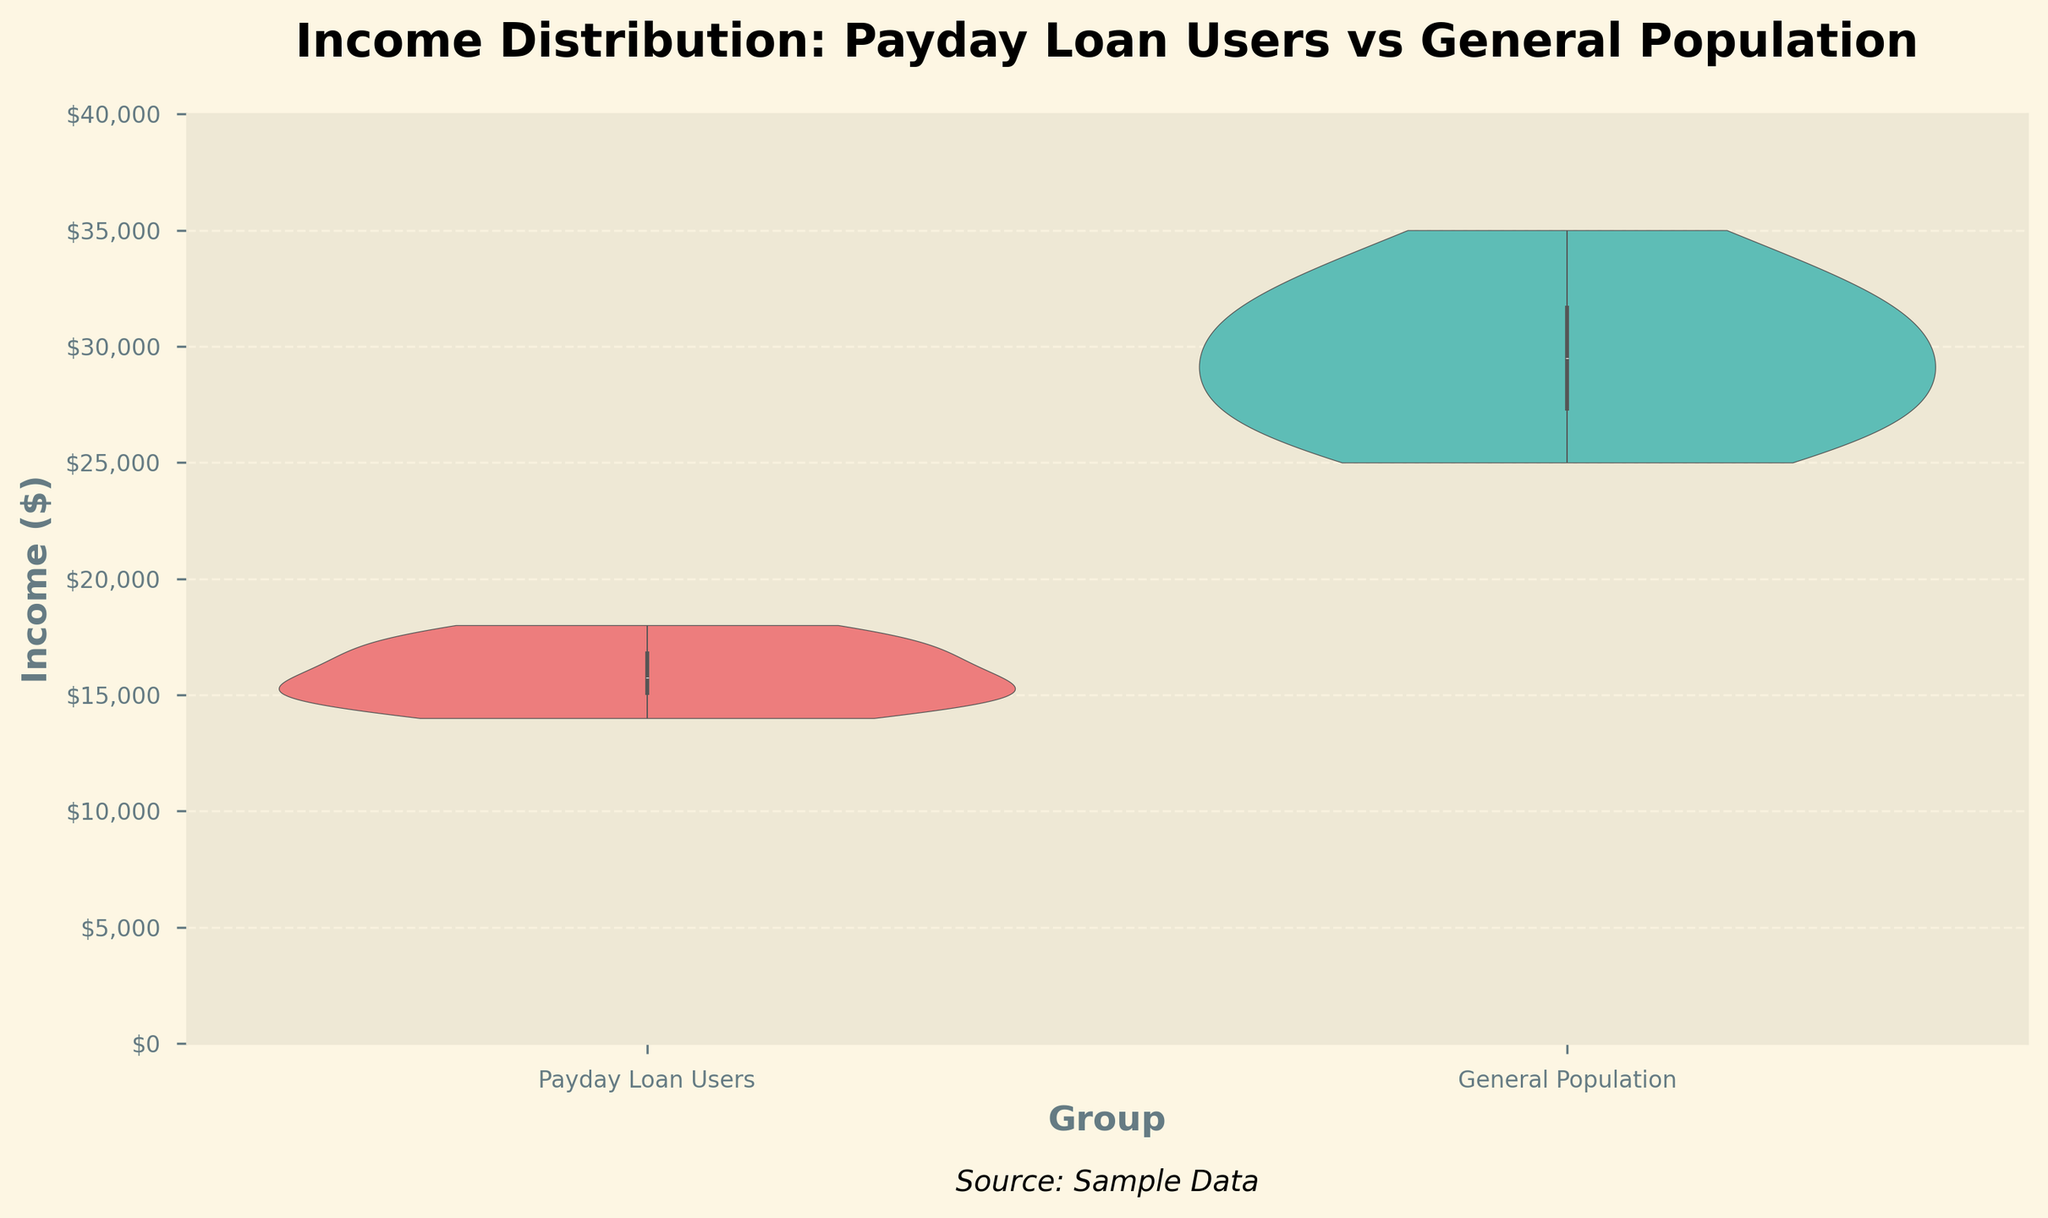What is the title of the figure? The title of the figure is located at the top and provides a summary of what the figure represents. By referring to the figure, we can see the title mentioned in bold font.
Answer: Income Distribution: Payday Loan Users vs General Population What is the highest income value shown on the y-axis? The y-axis represents the income levels and is marked with ticks ranging from 0 to 40,000. The highest tick mark visible on the y-axis can be observed directly from the figure.
Answer: $40,000 What colors are used for the groups in the figure? By referring to the colored sections of the violin plots in the figure, we can identify the distinct colors used for each group. The Payday Loan Users group is represented by one color, and the General Population group by another.
Answer: Payday Loan Users: pale red, General Population: teal What group tends to have a higher median income based on the violin plot? The figure presents violin plots for both groups, each with a boxplot inside it. By comparing the central white dots or lines within the boxplots, we can determine which group has a higher median income.
Answer: General Population Which group has a wider income distribution? Violin plots depict the distribution and spread of data. By comparing the widths of the violin plots for both groups, we can identify which group has a larger spread in their income distribution.
Answer: General Population What is the approximate median income of the General Population? The approximate median can be inferred from the central dot/line inside the boxplot of the General Population's violin plot. It indicates the middle value of the income distribution. By observing that position relative to the y-axis, we can estimate the median income.
Answer: Approximately $30,000 Does the Payday Loan Users group have more lower-income individuals compared to the General Population? By looking at the density and spread of the violin plot of the Payday Loan Users group, especially in the lower-income region, we can analyze if there is a higher concentration of individuals with lower income. The wider the plot at the lower end, the higher the concentration.
Answer: Yes What is the source of the data used in the figure? Below the x-axis, typically on the bottom margin of the figure, there's a text annotation that usually indicates the source of the data. Observing that text will provide the answer.
Answer: Sample Data Between what income ranges do both groups have the densest distributions? By examining the widest parts of each violin plot, we can identify where the densest concentrations of data lie for each group. The y-axis helps to determine the income ranges corresponding to these wide sections.
Answer: Payday Loan Users: $14,000 - $18,000, General Population: $25,000 - $35,000 